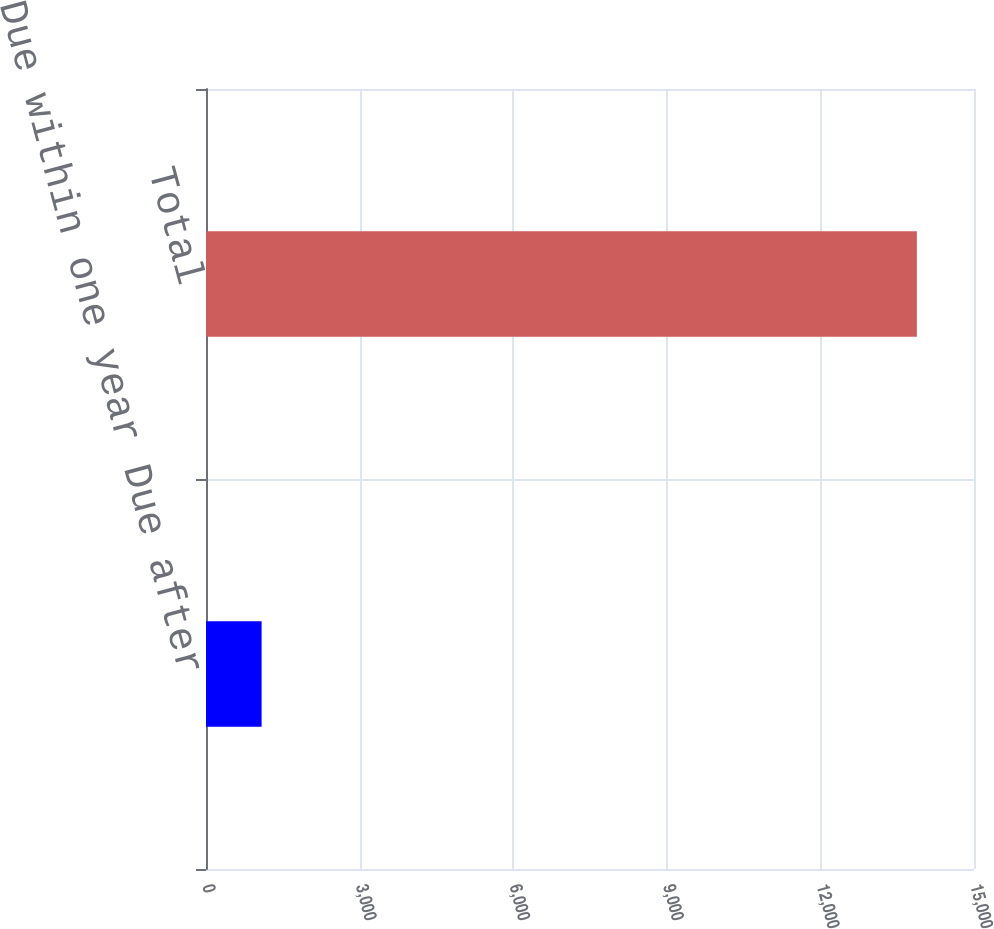Convert chart to OTSL. <chart><loc_0><loc_0><loc_500><loc_500><bar_chart><fcel>Due within one year Due after<fcel>Total<nl><fcel>1086<fcel>13884<nl></chart> 